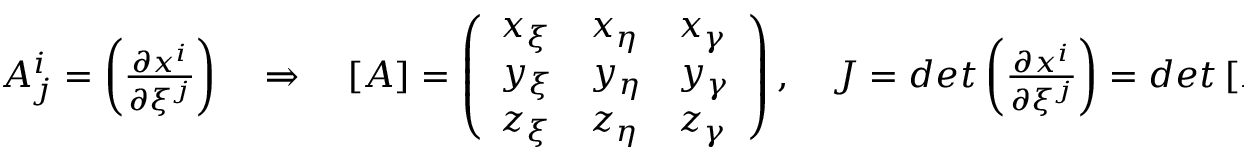Convert formula to latex. <formula><loc_0><loc_0><loc_500><loc_500>\begin{array} { r } { A _ { j } ^ { i } = \left ( \frac { \partial x ^ { i } } { \partial \xi ^ { j } } \right ) \quad \Rightarrow \quad \left [ A \right ] = \left ( \begin{array} { l l l } { x _ { \xi } } & { x _ { \eta } } & { x _ { \gamma } } \\ { y _ { \xi } } & { y _ { \eta } } & { y _ { \gamma } } \\ { z _ { \xi } } & { z _ { \eta } } & { z _ { \gamma } } \end{array} \right ) , \quad J = d e t \left ( \frac { \partial x ^ { i } } { \partial \xi ^ { j } } \right ) = d e t \left [ A \right ] , } \end{array}</formula> 